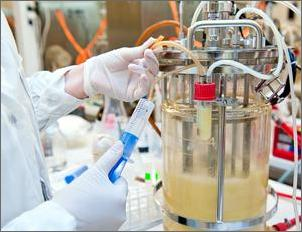Which of the following could Emilia's test show? Based on the visual cues from the setup depicted in the image, which includes a bioreactor likely used for culturing microorganisms, Emilia's test could primarily show whether the addition of specific nutrients enhanced the bacteria's ability to produce 20% more insulin. This can be measured using quantitative biotechnological assays that assess the concentration or activity level of insulin in the culture medium after the nutrient enrichment compared to a control setup without the nutrient boost. 